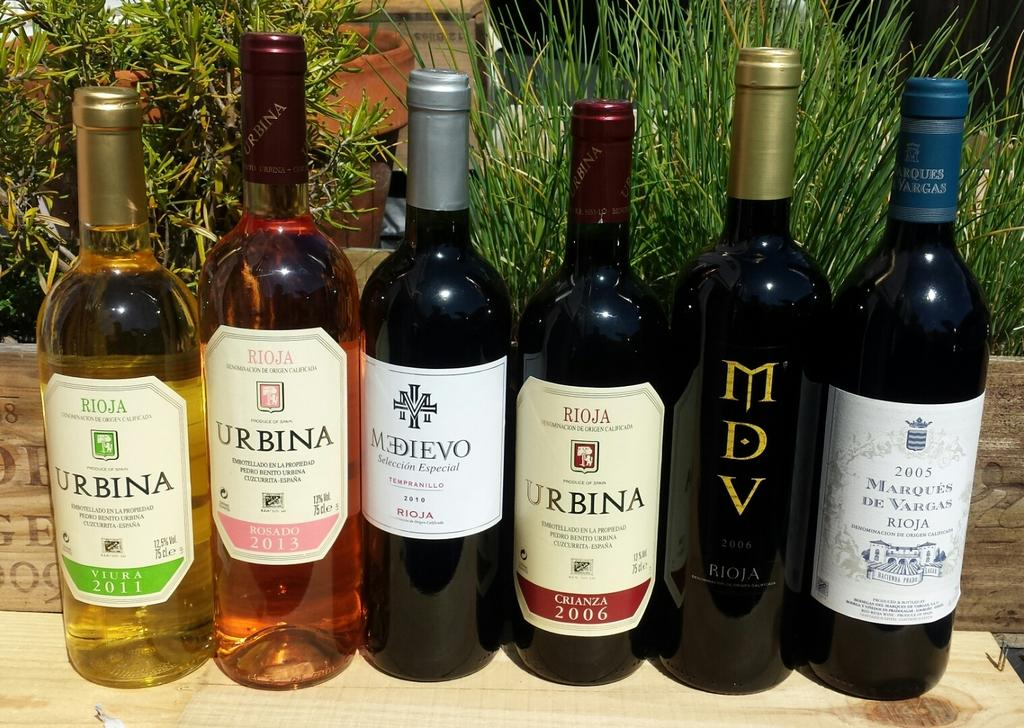<image>
Write a terse but informative summary of the picture. the word urbina is on a wine bottle 